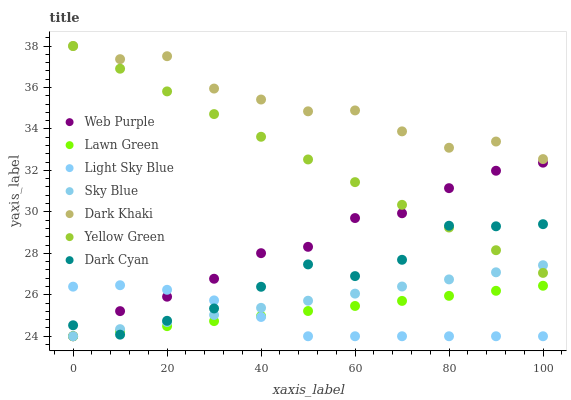Does Light Sky Blue have the minimum area under the curve?
Answer yes or no. Yes. Does Dark Khaki have the maximum area under the curve?
Answer yes or no. Yes. Does Yellow Green have the minimum area under the curve?
Answer yes or no. No. Does Yellow Green have the maximum area under the curve?
Answer yes or no. No. Is Lawn Green the smoothest?
Answer yes or no. Yes. Is Dark Khaki the roughest?
Answer yes or no. Yes. Is Yellow Green the smoothest?
Answer yes or no. No. Is Yellow Green the roughest?
Answer yes or no. No. Does Lawn Green have the lowest value?
Answer yes or no. Yes. Does Yellow Green have the lowest value?
Answer yes or no. No. Does Dark Khaki have the highest value?
Answer yes or no. Yes. Does Web Purple have the highest value?
Answer yes or no. No. Is Lawn Green less than Yellow Green?
Answer yes or no. Yes. Is Yellow Green greater than Light Sky Blue?
Answer yes or no. Yes. Does Yellow Green intersect Dark Cyan?
Answer yes or no. Yes. Is Yellow Green less than Dark Cyan?
Answer yes or no. No. Is Yellow Green greater than Dark Cyan?
Answer yes or no. No. Does Lawn Green intersect Yellow Green?
Answer yes or no. No. 